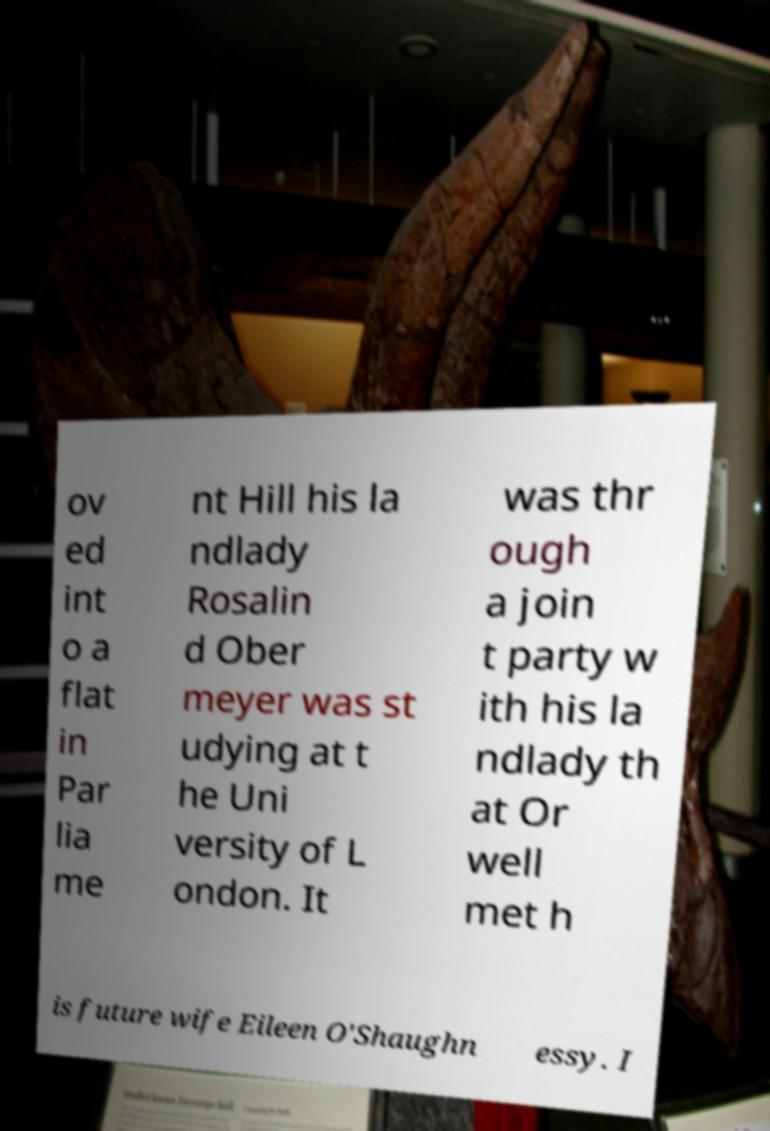Can you read and provide the text displayed in the image?This photo seems to have some interesting text. Can you extract and type it out for me? ov ed int o a flat in Par lia me nt Hill his la ndlady Rosalin d Ober meyer was st udying at t he Uni versity of L ondon. It was thr ough a join t party w ith his la ndlady th at Or well met h is future wife Eileen O'Shaughn essy. I 